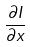Convert formula to latex. <formula><loc_0><loc_0><loc_500><loc_500>\frac { \partial I } { \partial x }</formula> 